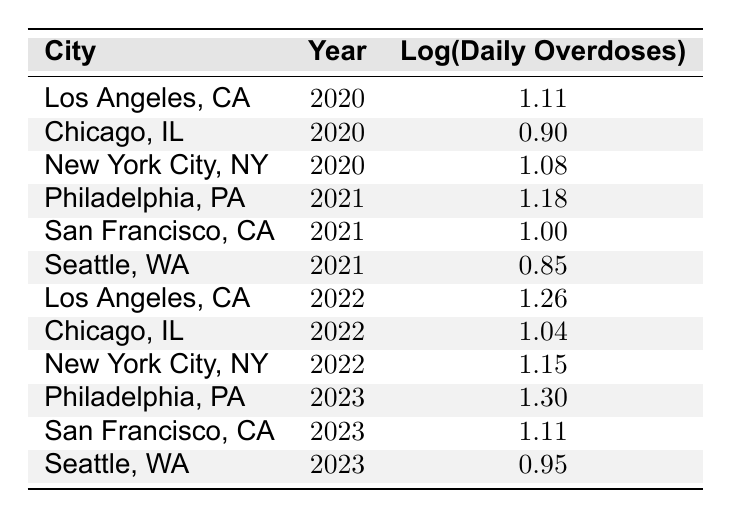What is the daily overdose rate in Los Angeles, CA for the year 2022? From the table, by looking at the row for Los Angeles, CA in the year 2022, I see the daily overdose rate listed is 18.
Answer: 18 What is the logarithmic value of daily overdoses in New York City, NY for the year 2020? The table shows that for New York City, NY in the year 2020, the logarithmic value of daily overdoses is 1.08.
Answer: 1.08 Is the daily overdose rate higher in Philadelphia, PA in 2023 compared to San Francisco, CA in 2023? By comparing the values in the table, I see that Philadelphia, PA has a daily overdose rate of 20 and San Francisco, CA has a daily overdose rate of 13 in 2023. Since 20 > 13, the statement is true.
Answer: Yes What is the average daily overdose rate across all cities in 2021? The daily overdose rates in 2021 are 15 (Philadelphia), 10 (San Francisco), and 7 (Seattle). Summing these gives 15 + 10 + 7 = 32. Dividing by the number of data points (3 cities) gives an average of 32/3 ≈ 10.67.
Answer: 10.67 Was there a decrease in the daily overdose rate from 2020 to 2021 in Chicago, IL? In Chicago, IL, the daily overdose rate in 2020 is 8, and in 2021 it is not directly stated but can be inferred from the rows of other cities, 2021 shows 15 for Philadelphia, which is a comparison. Since both are not the same comparison, I cannot make a definitive judgment without further data; thus, the statement cannot be evaluated as true or false.
Answer: No 